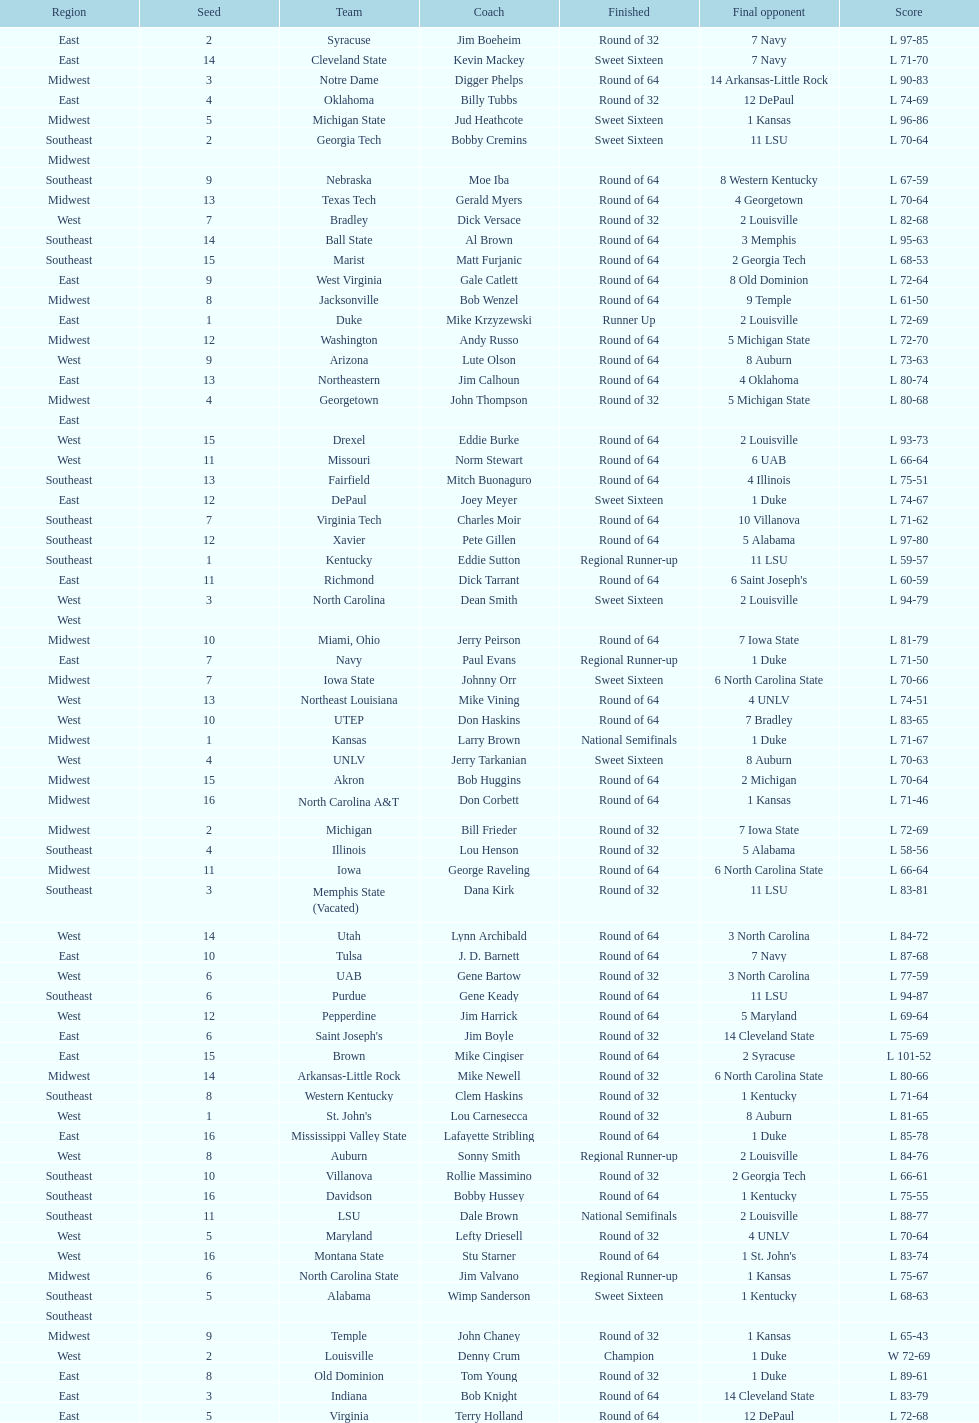Which team completed their journey as the top-ranking champions, outperforming all competitors? Louisville. 